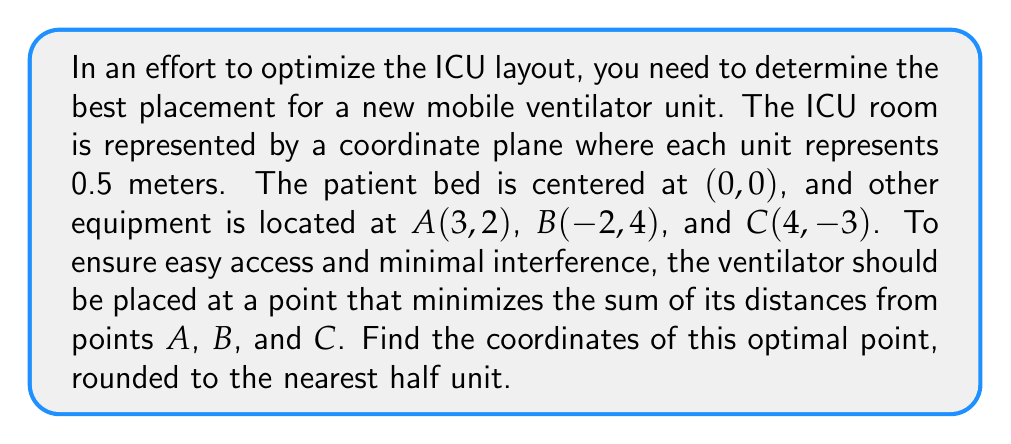Solve this math problem. To solve this problem, we need to use the concept of the geometric median, also known as the Fermat point. This point minimizes the sum of distances to a given set of points. While there's no closed-form solution for the geometric median, we can use an iterative method called the Weiszfeld algorithm.

1) First, let's define our initial guess as the centroid of the triangle formed by A, B, and C:

   $$ x_0 = \frac{3 + (-2) + 4}{3} = \frac{5}{3}, \quad y_0 = \frac{2 + 4 + (-3)}{3} = 1 $$

2) The Weiszfeld algorithm uses the following update rule:

   $$ x_{n+1} = \frac{\sum_{i=1}^m \frac{x_i}{d_i}}{\sum_{i=1}^m \frac{1}{d_i}}, \quad y_{n+1} = \frac{\sum_{i=1}^m \frac{y_i}{d_i}}{\sum_{i=1}^m \frac{1}{d_i}} $$

   where $(x_i, y_i)$ are the coordinates of each point, and $d_i$ is the distance from the current estimate to point i.

3) Let's perform a few iterations:

   Iteration 1:
   $d_A = \sqrt{(5/3 - 3)^2 + (1 - 2)^2} = 1.75$
   $d_B = \sqrt{(5/3 - (-2))^2 + (1 - 4)^2} = 4.19$
   $d_C = \sqrt{(5/3 - 4)^2 + (1 - (-3))^2} = 4.54$

   $x_1 = \frac{3/1.75 + (-2)/4.19 + 4/4.54}{1/1.75 + 1/4.19 + 1/4.54} = 1.82$
   $y_1 = \frac{2/1.75 + 4/4.19 + (-3)/4.54}{1/1.75 + 1/4.19 + 1/4.54} = 1.09$

   Iteration 2:
   $d_A = 1.29$, $d_B = 4.31$, $d_C = 4.67$

   $x_2 = 1.77$, $y_2 = 1.13$

   Iteration 3:
   $d_A = 1.33$, $d_B = 4.28$, $d_C = 4.64$

   $x_3 = 1.76$, $y_3 = 1.14$

4) The algorithm converges quickly, so we can stop here and round to the nearest half unit.

5) Converting back to the original scale (multiply by 0.5):
   $(1.76 * 0.5, 1.14 * 0.5) = (0.88, 0.57)$

6) Rounding to the nearest half unit:
   $(0.88, 0.57) \approx (1, 0.5)$
Answer: The optimal placement for the mobile ventilator unit is at coordinates (1, 0.5) in the ICU room coordinate system. 